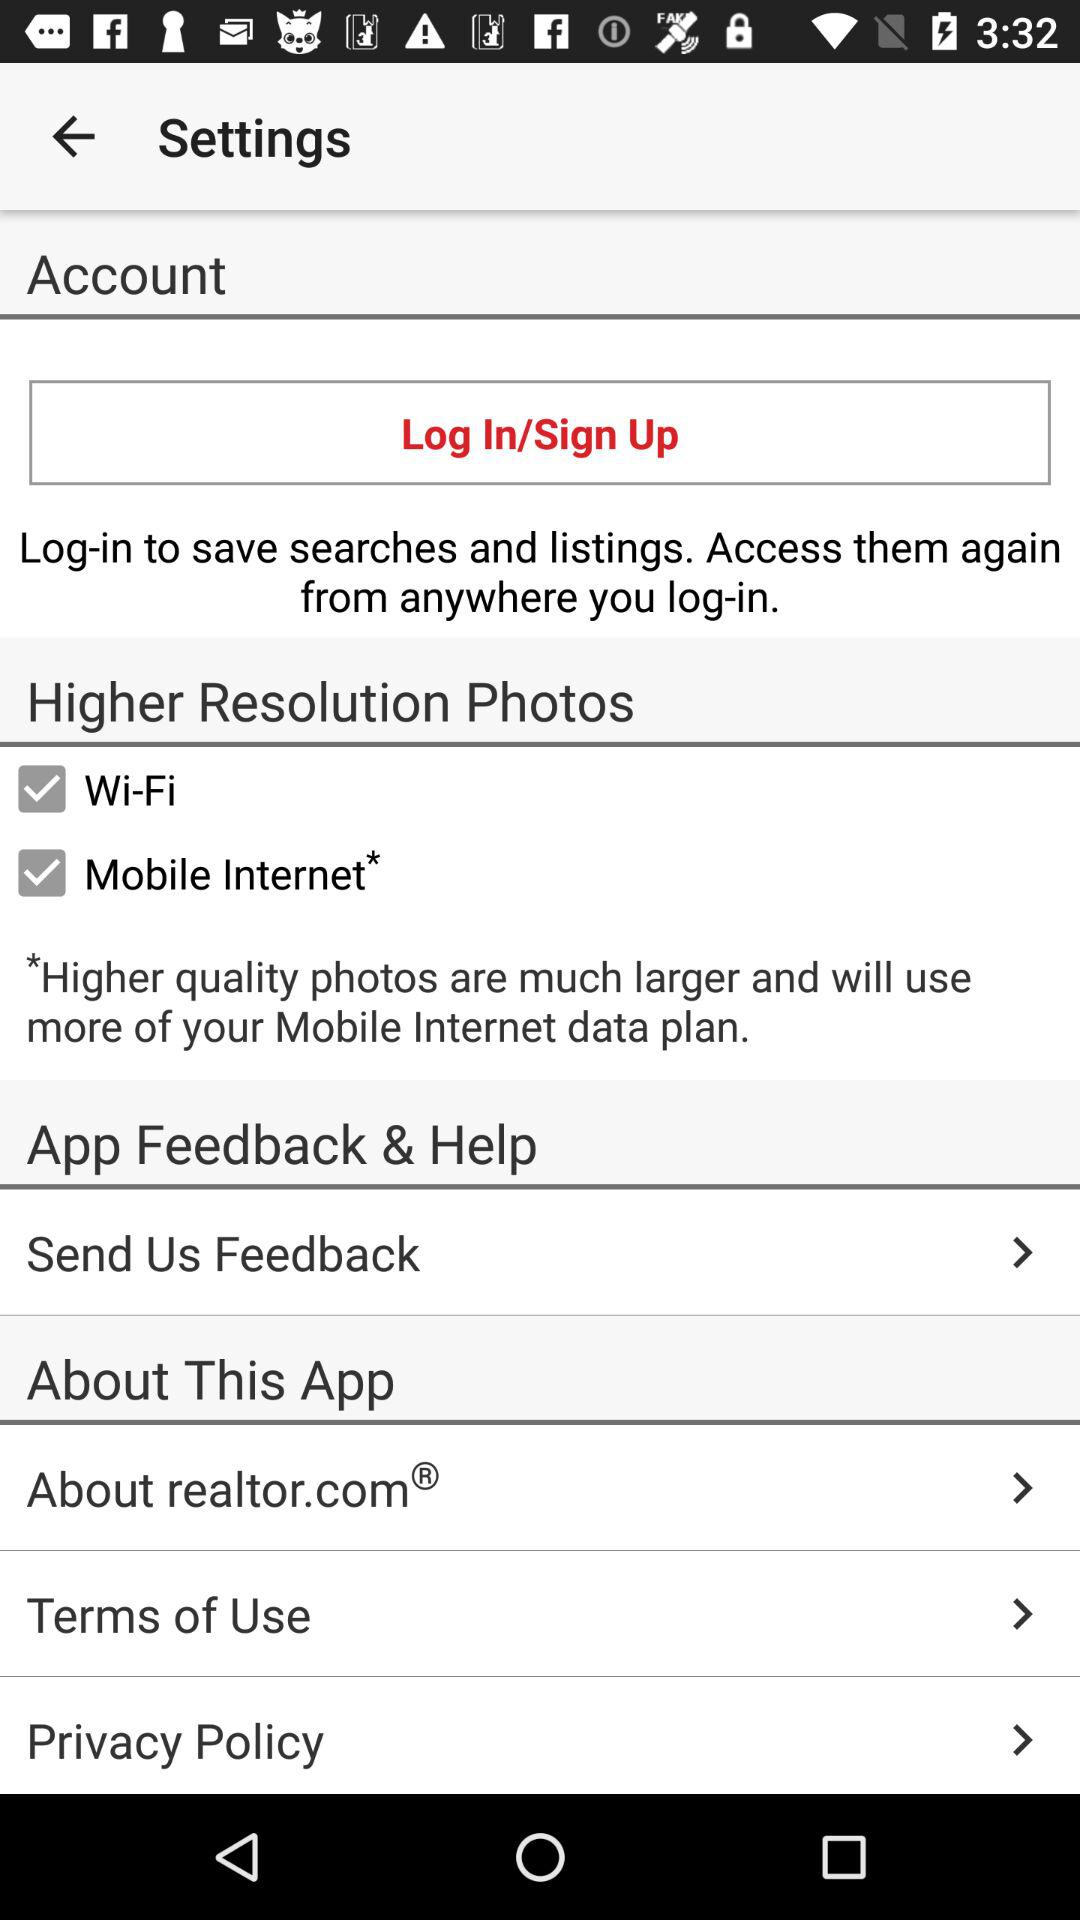What are the options selected for "Higher Resolution Photos"? The selected options are "Wi-Fi" and "Mobile Internet". 